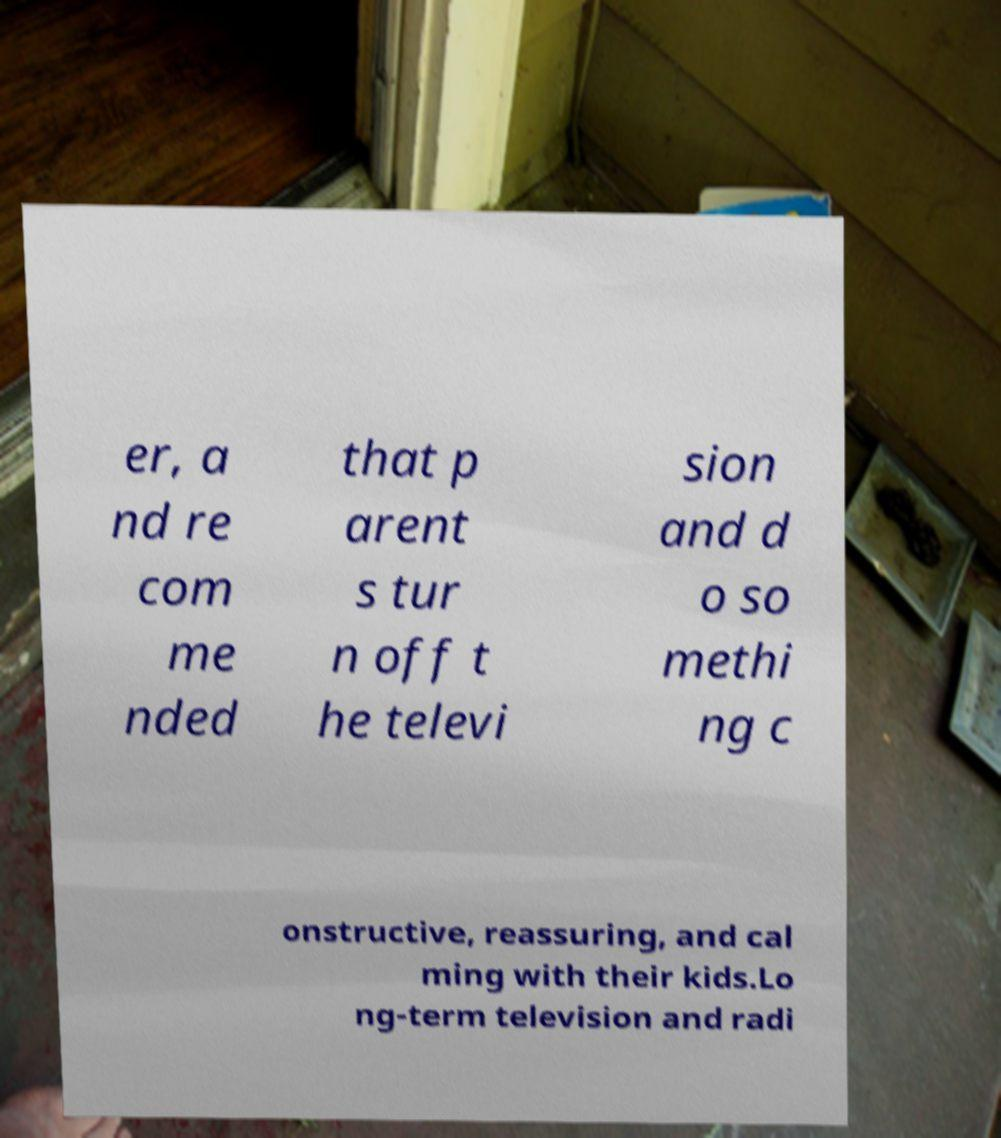What messages or text are displayed in this image? I need them in a readable, typed format. er, a nd re com me nded that p arent s tur n off t he televi sion and d o so methi ng c onstructive, reassuring, and cal ming with their kids.Lo ng-term television and radi 